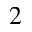Convert formula to latex. <formula><loc_0><loc_0><loc_500><loc_500>^ { 2 }</formula> 